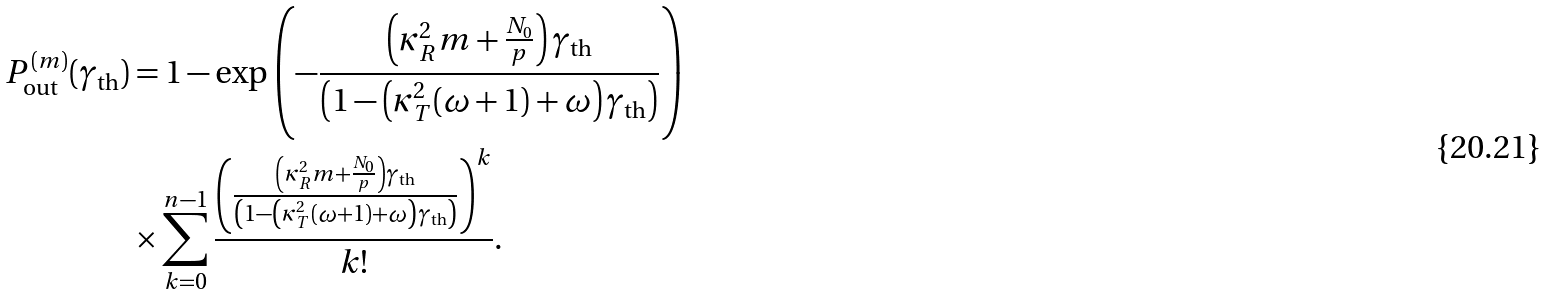<formula> <loc_0><loc_0><loc_500><loc_500>P ^ { ( m ) } _ { \text {out} } ( \gamma _ { \text {th} } ) & = 1 - \exp \left ( - \frac { \left ( \kappa ^ { 2 } _ { R } m + \frac { N _ { 0 } } { p } \right ) \gamma _ { \text {th} } } { \left ( 1 - \left ( \kappa ^ { 2 } _ { T } ( \omega + 1 ) + \omega \right ) \gamma _ { \text {th} } \right ) } \right ) \\ & \times \sum ^ { n - 1 } _ { k = 0 } \frac { \left ( \frac { \left ( \kappa ^ { 2 } _ { R } m + \frac { N _ { 0 } } { p } \right ) \gamma _ { \text {th} } } { \left ( 1 - \left ( \kappa ^ { 2 } _ { T } ( \omega + 1 ) + \omega \right ) \gamma _ { \text {th} } \right ) } \right ) ^ { k } } { k ! } .</formula> 